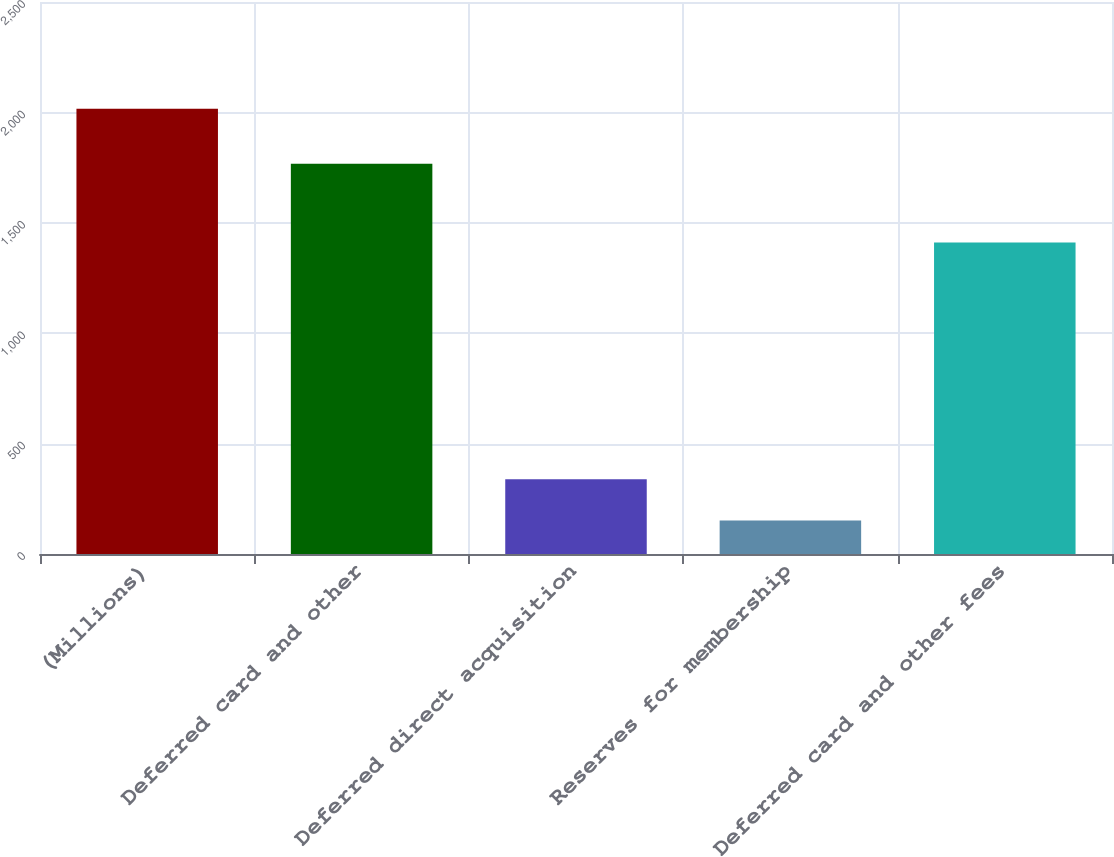Convert chart to OTSL. <chart><loc_0><loc_0><loc_500><loc_500><bar_chart><fcel>(Millions)<fcel>Deferred card and other<fcel>Deferred direct acquisition<fcel>Reserves for membership<fcel>Deferred card and other fees<nl><fcel>2016<fcel>1767<fcel>338.4<fcel>152<fcel>1411<nl></chart> 